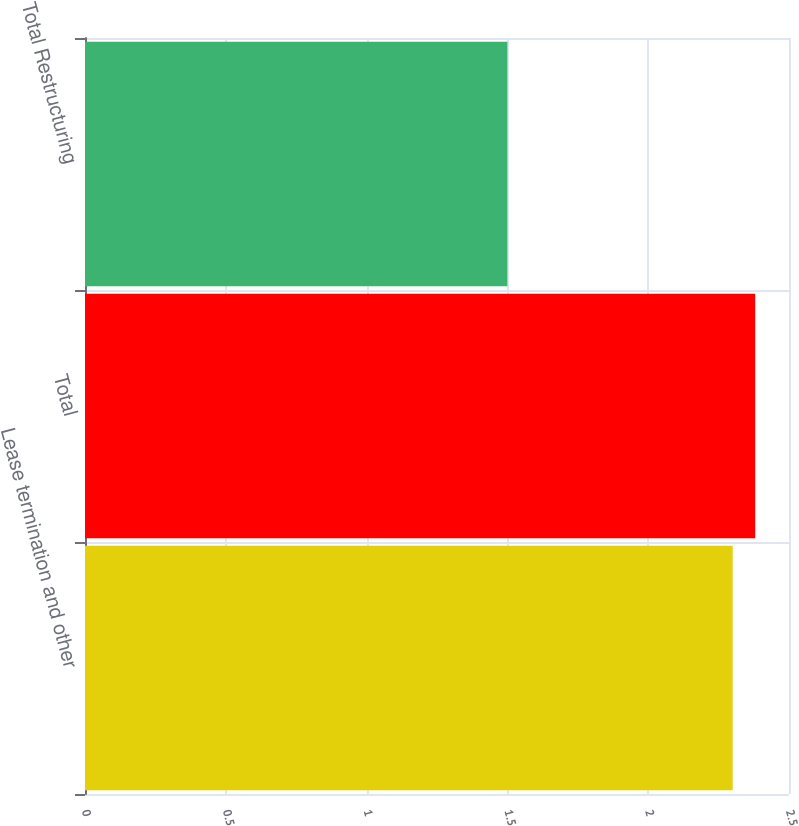Convert chart to OTSL. <chart><loc_0><loc_0><loc_500><loc_500><bar_chart><fcel>Lease termination and other<fcel>Total<fcel>Total Restructuring<nl><fcel>2.3<fcel>2.38<fcel>1.5<nl></chart> 